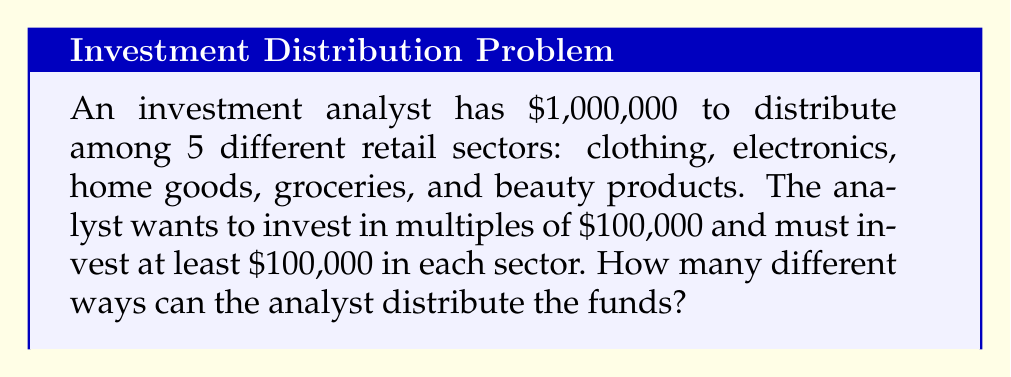Can you solve this math problem? Let's approach this step-by-step:

1) First, we need to recognize that this is a stars and bars problem with constraints.

2) We have $1,000,000 to distribute, in units of $100,000. So effectively, we're distributing 10 units among 5 sectors.

3) The constraint is that each sector must receive at least 1 unit ($100,000).

4) To account for this constraint, we can first give each sector 1 unit. This leaves us with 5 units to distribute freely.

5) Now, our problem has been reduced to: In how many ways can we distribute 5 identical objects (remaining $500,000) into 5 distinct boxes (sectors)?

6) This is a classic stars and bars problem. The formula for this is:

   $$\binom{n+k-1}{k-1}$$

   where $n$ is the number of identical objects and $k$ is the number of distinct boxes.

7) In our case, $n = 5$ (remaining $500,000 to distribute) and $k = 5$ (5 sectors).

8) Plugging into the formula:

   $$\binom{5+5-1}{5-1} = \binom{9}{4}$$

9) We can calculate this:

   $$\binom{9}{4} = \frac{9!}{4!(9-4)!} = \frac{9!}{4!5!} = 126$$

Therefore, there are 126 different ways to distribute the funds.
Answer: 126 